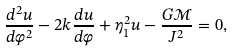<formula> <loc_0><loc_0><loc_500><loc_500>\frac { d ^ { 2 } u } { d \varphi ^ { 2 } } - 2 k \frac { d u } { d \varphi } + \eta _ { 1 } ^ { 2 } u - \frac { G \mathcal { M } } { J ^ { 2 } } = 0 ,</formula> 